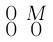Convert formula to latex. <formula><loc_0><loc_0><loc_500><loc_500>\begin{smallmatrix} 0 & M \\ 0 & 0 \end{smallmatrix}</formula> 